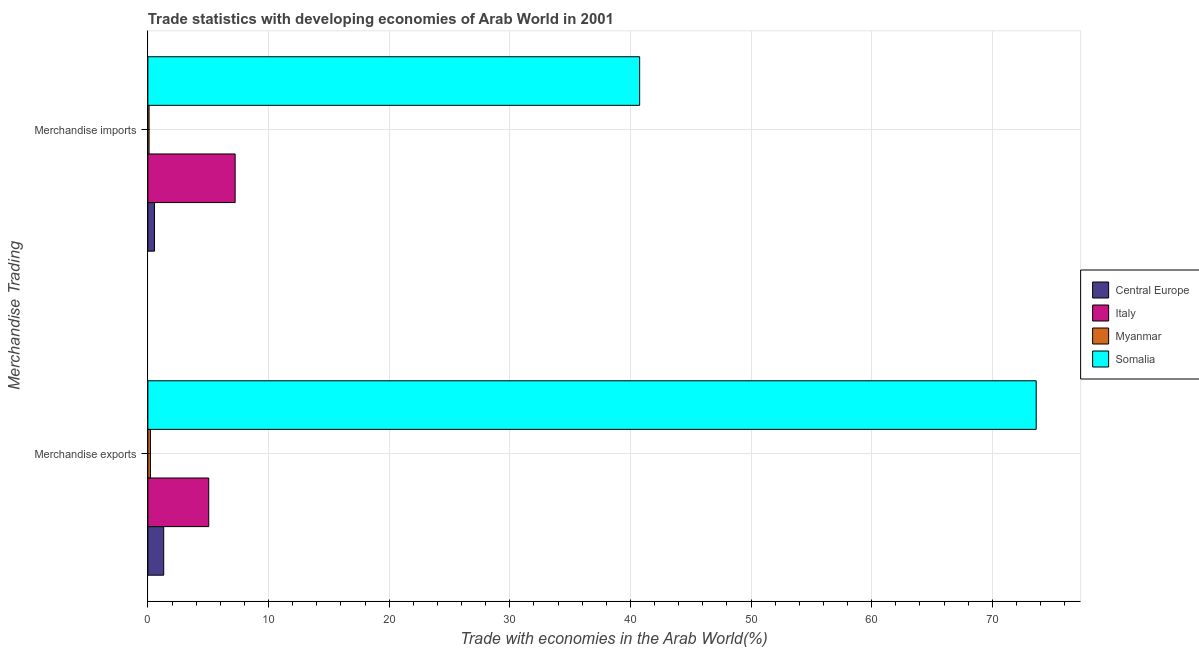How many different coloured bars are there?
Your answer should be compact. 4. How many groups of bars are there?
Your answer should be compact. 2. Are the number of bars on each tick of the Y-axis equal?
Provide a succinct answer. Yes. How many bars are there on the 1st tick from the bottom?
Keep it short and to the point. 4. What is the merchandise imports in Somalia?
Provide a short and direct response. 40.77. Across all countries, what is the maximum merchandise imports?
Provide a succinct answer. 40.77. Across all countries, what is the minimum merchandise imports?
Your answer should be compact. 0.1. In which country was the merchandise imports maximum?
Offer a very short reply. Somalia. In which country was the merchandise exports minimum?
Ensure brevity in your answer.  Myanmar. What is the total merchandise imports in the graph?
Your answer should be compact. 48.65. What is the difference between the merchandise exports in Italy and that in Somalia?
Your response must be concise. -68.59. What is the difference between the merchandise exports in Central Europe and the merchandise imports in Somalia?
Your answer should be very brief. -39.45. What is the average merchandise imports per country?
Your answer should be compact. 12.16. What is the difference between the merchandise imports and merchandise exports in Italy?
Your answer should be very brief. 2.19. In how many countries, is the merchandise imports greater than 52 %?
Make the answer very short. 0. What is the ratio of the merchandise imports in Myanmar to that in Somalia?
Provide a succinct answer. 0. Is the merchandise imports in Myanmar less than that in Central Europe?
Provide a succinct answer. Yes. What does the 3rd bar from the top in Merchandise imports represents?
Your response must be concise. Italy. What does the 4th bar from the bottom in Merchandise imports represents?
Your response must be concise. Somalia. How many bars are there?
Offer a terse response. 8. Are all the bars in the graph horizontal?
Offer a very short reply. Yes. Are the values on the major ticks of X-axis written in scientific E-notation?
Make the answer very short. No. Does the graph contain any zero values?
Make the answer very short. No. How many legend labels are there?
Offer a very short reply. 4. How are the legend labels stacked?
Make the answer very short. Vertical. What is the title of the graph?
Keep it short and to the point. Trade statistics with developing economies of Arab World in 2001. Does "Lebanon" appear as one of the legend labels in the graph?
Your answer should be compact. No. What is the label or title of the X-axis?
Ensure brevity in your answer.  Trade with economies in the Arab World(%). What is the label or title of the Y-axis?
Your response must be concise. Merchandise Trading. What is the Trade with economies in the Arab World(%) of Central Europe in Merchandise exports?
Your answer should be compact. 1.31. What is the Trade with economies in the Arab World(%) in Italy in Merchandise exports?
Your answer should be very brief. 5.05. What is the Trade with economies in the Arab World(%) of Myanmar in Merchandise exports?
Your response must be concise. 0.21. What is the Trade with economies in the Arab World(%) in Somalia in Merchandise exports?
Provide a succinct answer. 73.64. What is the Trade with economies in the Arab World(%) of Central Europe in Merchandise imports?
Provide a short and direct response. 0.55. What is the Trade with economies in the Arab World(%) of Italy in Merchandise imports?
Provide a short and direct response. 7.23. What is the Trade with economies in the Arab World(%) of Myanmar in Merchandise imports?
Offer a terse response. 0.1. What is the Trade with economies in the Arab World(%) of Somalia in Merchandise imports?
Your answer should be compact. 40.77. Across all Merchandise Trading, what is the maximum Trade with economies in the Arab World(%) of Central Europe?
Provide a short and direct response. 1.31. Across all Merchandise Trading, what is the maximum Trade with economies in the Arab World(%) of Italy?
Keep it short and to the point. 7.23. Across all Merchandise Trading, what is the maximum Trade with economies in the Arab World(%) in Myanmar?
Your answer should be very brief. 0.21. Across all Merchandise Trading, what is the maximum Trade with economies in the Arab World(%) of Somalia?
Give a very brief answer. 73.64. Across all Merchandise Trading, what is the minimum Trade with economies in the Arab World(%) of Central Europe?
Keep it short and to the point. 0.55. Across all Merchandise Trading, what is the minimum Trade with economies in the Arab World(%) in Italy?
Give a very brief answer. 5.05. Across all Merchandise Trading, what is the minimum Trade with economies in the Arab World(%) of Myanmar?
Ensure brevity in your answer.  0.1. Across all Merchandise Trading, what is the minimum Trade with economies in the Arab World(%) of Somalia?
Keep it short and to the point. 40.77. What is the total Trade with economies in the Arab World(%) of Central Europe in the graph?
Make the answer very short. 1.86. What is the total Trade with economies in the Arab World(%) in Italy in the graph?
Your answer should be compact. 12.28. What is the total Trade with economies in the Arab World(%) in Myanmar in the graph?
Keep it short and to the point. 0.31. What is the total Trade with economies in the Arab World(%) of Somalia in the graph?
Ensure brevity in your answer.  114.4. What is the difference between the Trade with economies in the Arab World(%) in Central Europe in Merchandise exports and that in Merchandise imports?
Provide a succinct answer. 0.77. What is the difference between the Trade with economies in the Arab World(%) in Italy in Merchandise exports and that in Merchandise imports?
Give a very brief answer. -2.19. What is the difference between the Trade with economies in the Arab World(%) of Myanmar in Merchandise exports and that in Merchandise imports?
Offer a terse response. 0.11. What is the difference between the Trade with economies in the Arab World(%) of Somalia in Merchandise exports and that in Merchandise imports?
Offer a very short reply. 32.87. What is the difference between the Trade with economies in the Arab World(%) of Central Europe in Merchandise exports and the Trade with economies in the Arab World(%) of Italy in Merchandise imports?
Make the answer very short. -5.92. What is the difference between the Trade with economies in the Arab World(%) of Central Europe in Merchandise exports and the Trade with economies in the Arab World(%) of Myanmar in Merchandise imports?
Your answer should be compact. 1.21. What is the difference between the Trade with economies in the Arab World(%) in Central Europe in Merchandise exports and the Trade with economies in the Arab World(%) in Somalia in Merchandise imports?
Provide a succinct answer. -39.45. What is the difference between the Trade with economies in the Arab World(%) of Italy in Merchandise exports and the Trade with economies in the Arab World(%) of Myanmar in Merchandise imports?
Ensure brevity in your answer.  4.95. What is the difference between the Trade with economies in the Arab World(%) of Italy in Merchandise exports and the Trade with economies in the Arab World(%) of Somalia in Merchandise imports?
Your answer should be compact. -35.72. What is the difference between the Trade with economies in the Arab World(%) in Myanmar in Merchandise exports and the Trade with economies in the Arab World(%) in Somalia in Merchandise imports?
Give a very brief answer. -40.55. What is the average Trade with economies in the Arab World(%) in Central Europe per Merchandise Trading?
Give a very brief answer. 0.93. What is the average Trade with economies in the Arab World(%) in Italy per Merchandise Trading?
Provide a short and direct response. 6.14. What is the average Trade with economies in the Arab World(%) of Myanmar per Merchandise Trading?
Give a very brief answer. 0.16. What is the average Trade with economies in the Arab World(%) of Somalia per Merchandise Trading?
Keep it short and to the point. 57.2. What is the difference between the Trade with economies in the Arab World(%) of Central Europe and Trade with economies in the Arab World(%) of Italy in Merchandise exports?
Your response must be concise. -3.73. What is the difference between the Trade with economies in the Arab World(%) in Central Europe and Trade with economies in the Arab World(%) in Myanmar in Merchandise exports?
Offer a terse response. 1.1. What is the difference between the Trade with economies in the Arab World(%) of Central Europe and Trade with economies in the Arab World(%) of Somalia in Merchandise exports?
Your answer should be very brief. -72.32. What is the difference between the Trade with economies in the Arab World(%) in Italy and Trade with economies in the Arab World(%) in Myanmar in Merchandise exports?
Keep it short and to the point. 4.83. What is the difference between the Trade with economies in the Arab World(%) in Italy and Trade with economies in the Arab World(%) in Somalia in Merchandise exports?
Give a very brief answer. -68.59. What is the difference between the Trade with economies in the Arab World(%) of Myanmar and Trade with economies in the Arab World(%) of Somalia in Merchandise exports?
Offer a very short reply. -73.42. What is the difference between the Trade with economies in the Arab World(%) in Central Europe and Trade with economies in the Arab World(%) in Italy in Merchandise imports?
Ensure brevity in your answer.  -6.69. What is the difference between the Trade with economies in the Arab World(%) of Central Europe and Trade with economies in the Arab World(%) of Myanmar in Merchandise imports?
Keep it short and to the point. 0.45. What is the difference between the Trade with economies in the Arab World(%) of Central Europe and Trade with economies in the Arab World(%) of Somalia in Merchandise imports?
Ensure brevity in your answer.  -40.22. What is the difference between the Trade with economies in the Arab World(%) of Italy and Trade with economies in the Arab World(%) of Myanmar in Merchandise imports?
Give a very brief answer. 7.13. What is the difference between the Trade with economies in the Arab World(%) in Italy and Trade with economies in the Arab World(%) in Somalia in Merchandise imports?
Provide a succinct answer. -33.53. What is the difference between the Trade with economies in the Arab World(%) in Myanmar and Trade with economies in the Arab World(%) in Somalia in Merchandise imports?
Provide a succinct answer. -40.67. What is the ratio of the Trade with economies in the Arab World(%) in Central Europe in Merchandise exports to that in Merchandise imports?
Make the answer very short. 2.4. What is the ratio of the Trade with economies in the Arab World(%) in Italy in Merchandise exports to that in Merchandise imports?
Provide a succinct answer. 0.7. What is the ratio of the Trade with economies in the Arab World(%) of Myanmar in Merchandise exports to that in Merchandise imports?
Give a very brief answer. 2.11. What is the ratio of the Trade with economies in the Arab World(%) in Somalia in Merchandise exports to that in Merchandise imports?
Provide a short and direct response. 1.81. What is the difference between the highest and the second highest Trade with economies in the Arab World(%) in Central Europe?
Your answer should be compact. 0.77. What is the difference between the highest and the second highest Trade with economies in the Arab World(%) in Italy?
Ensure brevity in your answer.  2.19. What is the difference between the highest and the second highest Trade with economies in the Arab World(%) in Myanmar?
Keep it short and to the point. 0.11. What is the difference between the highest and the second highest Trade with economies in the Arab World(%) in Somalia?
Offer a terse response. 32.87. What is the difference between the highest and the lowest Trade with economies in the Arab World(%) in Central Europe?
Offer a terse response. 0.77. What is the difference between the highest and the lowest Trade with economies in the Arab World(%) of Italy?
Offer a very short reply. 2.19. What is the difference between the highest and the lowest Trade with economies in the Arab World(%) of Myanmar?
Make the answer very short. 0.11. What is the difference between the highest and the lowest Trade with economies in the Arab World(%) of Somalia?
Your answer should be very brief. 32.87. 